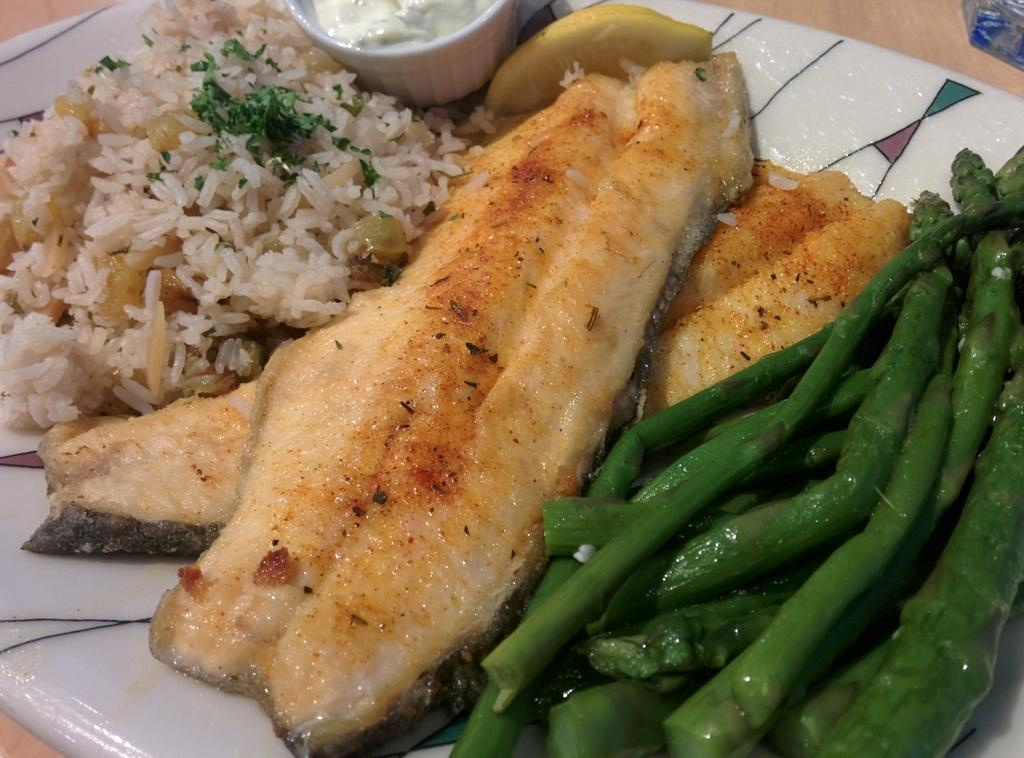What is on the plate in the image? There is food present on the plate in the image. What else can be seen on the table besides the plate? There is a cup in the image. How much money is the boy holding in the image? There is no boy present in the image, and therefore no money can be observed. 